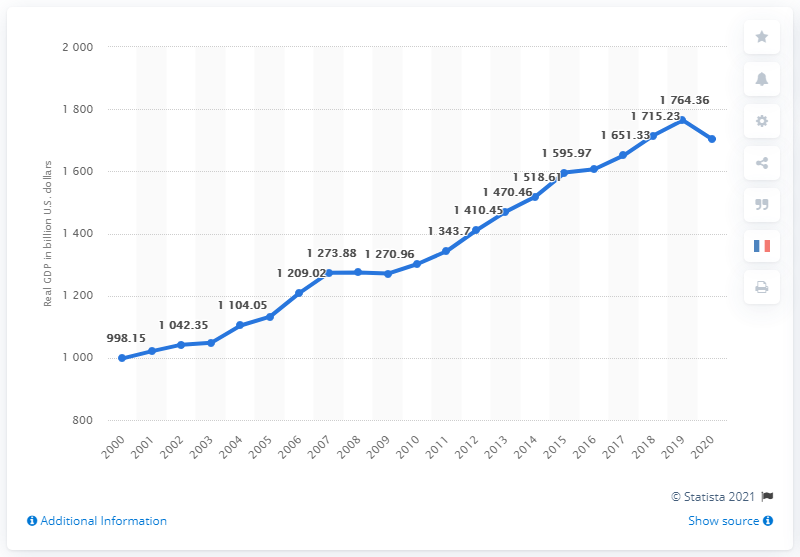List a handful of essential elements in this visual. The real GDP of Texas in 2020 was 1,703.07. In 1764, the real GDP of Texas was 1764.36 dollars. 